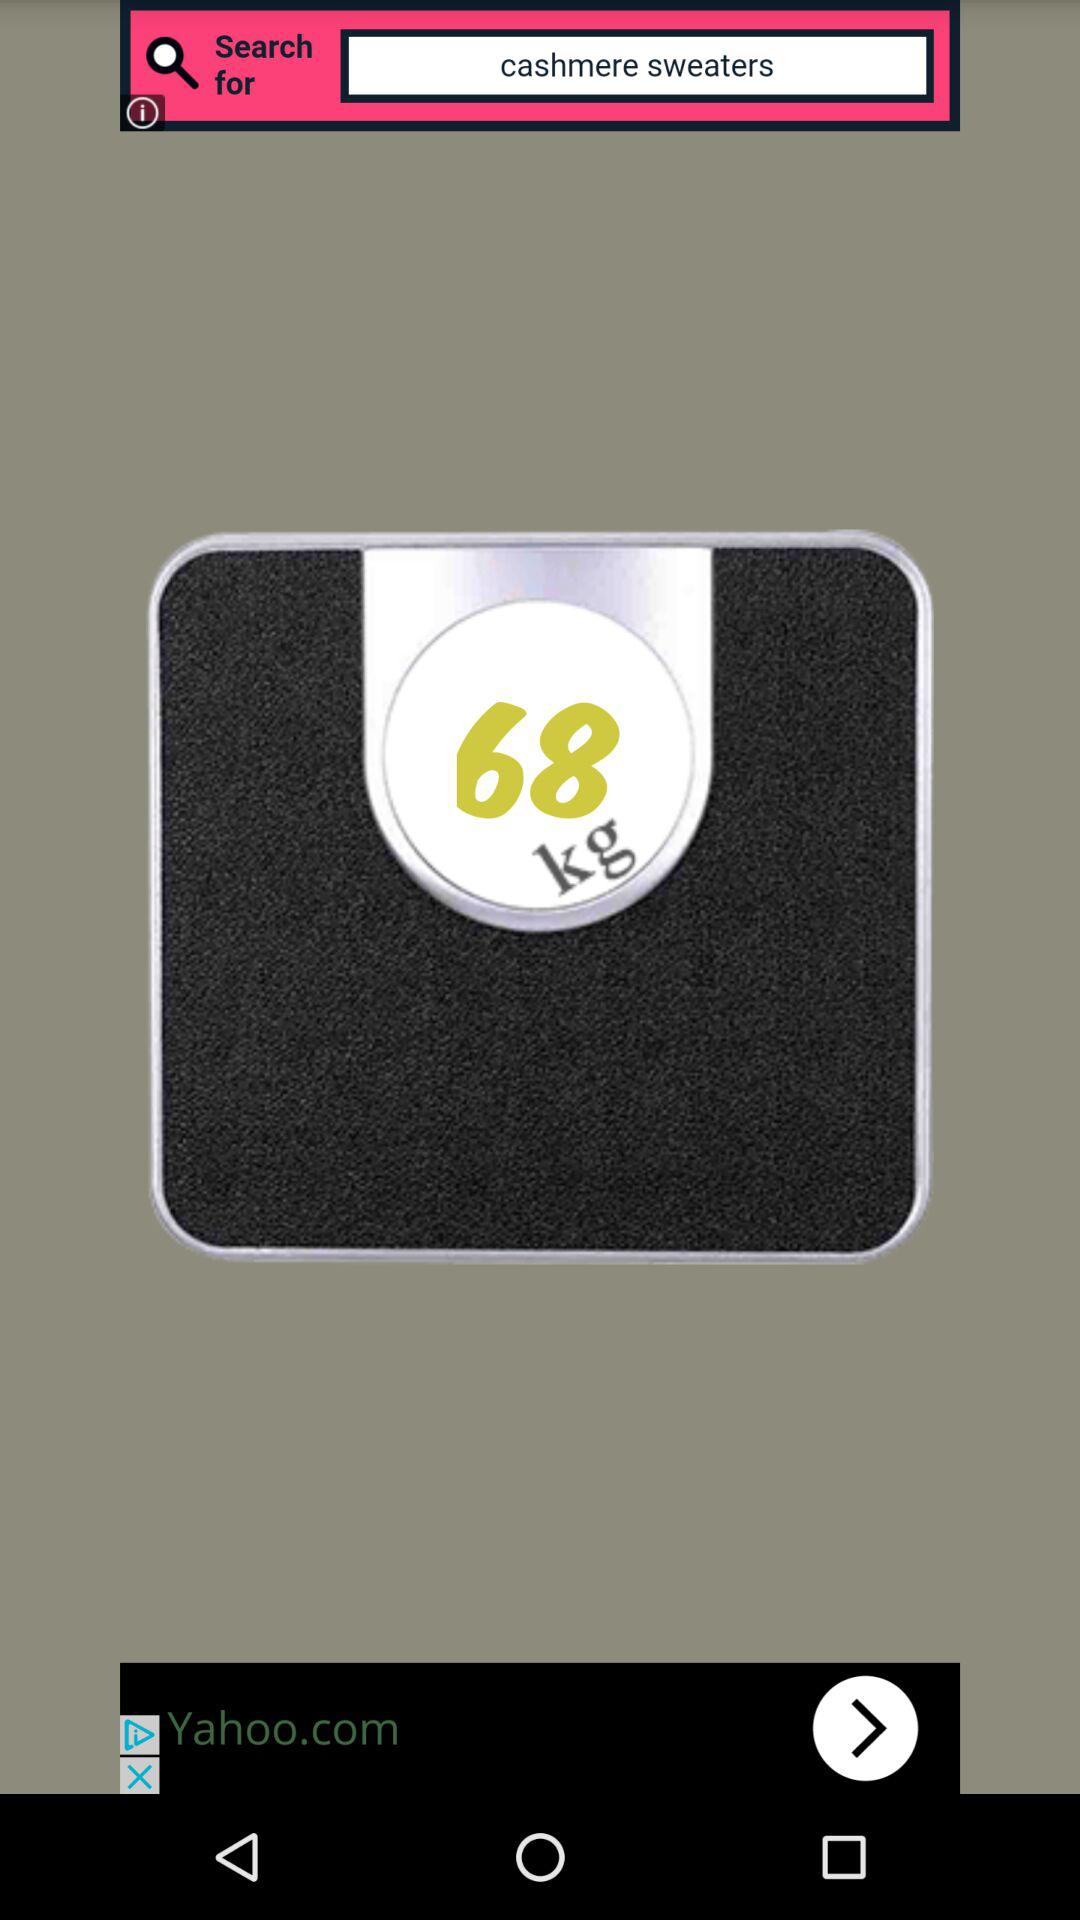What's the weight? The weight is 68 kg. 